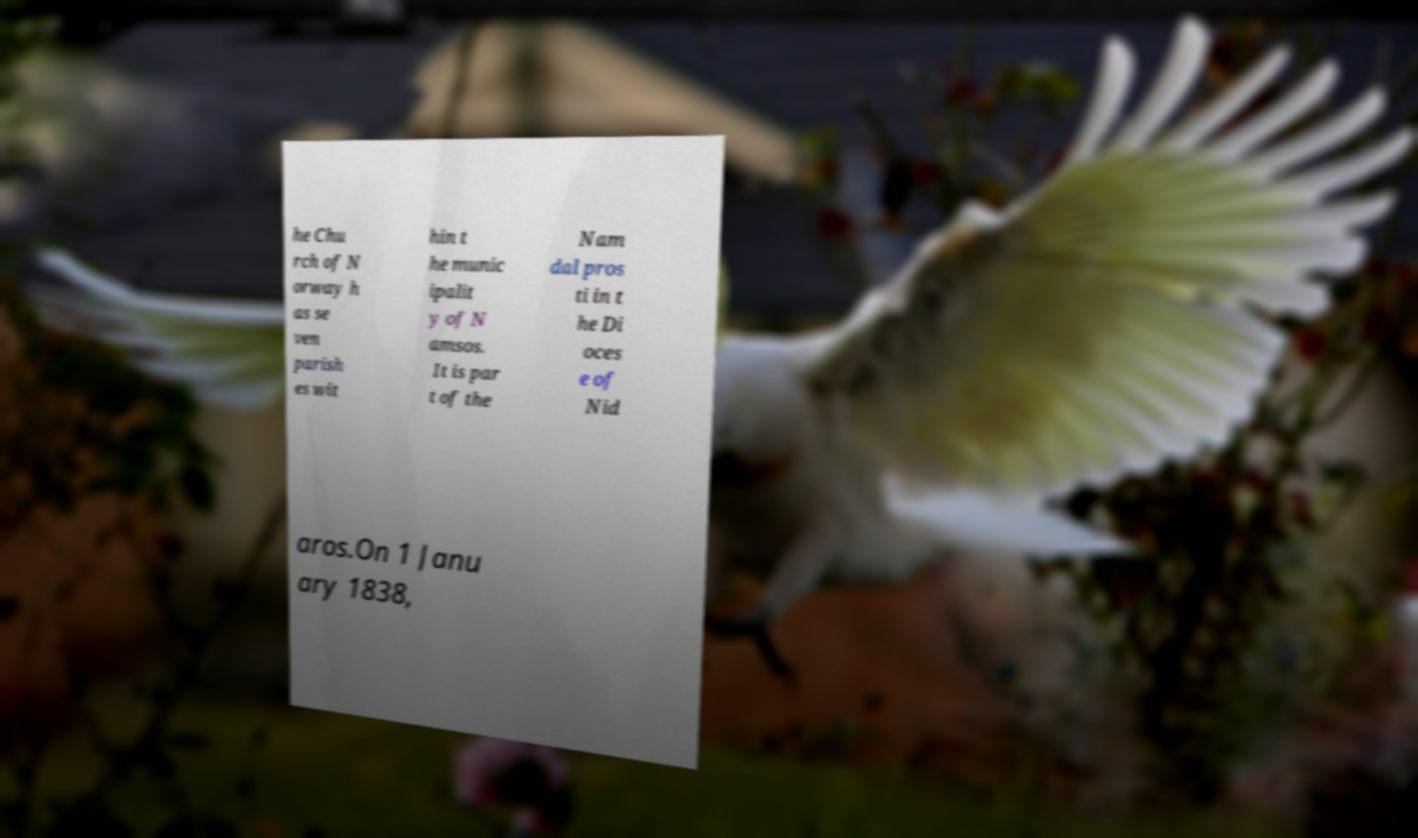I need the written content from this picture converted into text. Can you do that? he Chu rch of N orway h as se ven parish es wit hin t he munic ipalit y of N amsos. It is par t of the Nam dal pros ti in t he Di oces e of Nid aros.On 1 Janu ary 1838, 